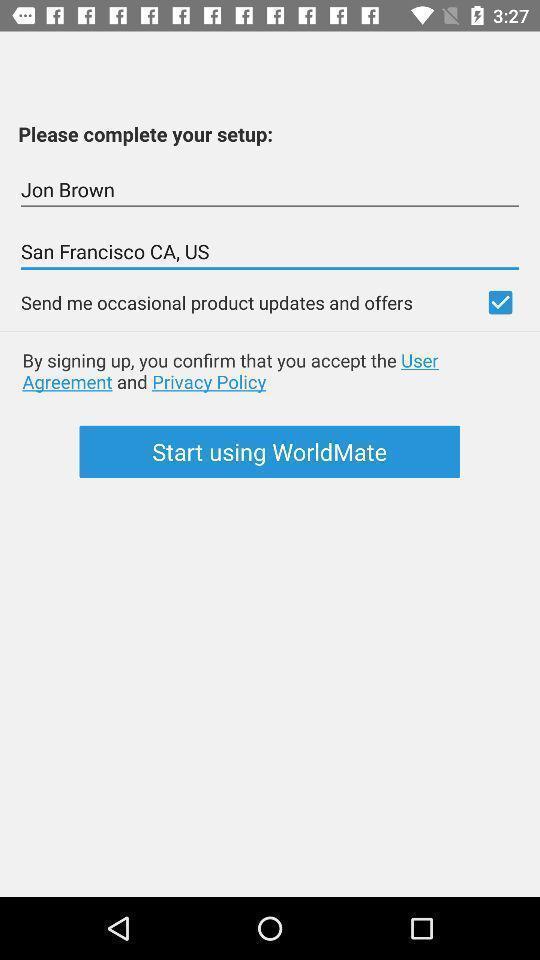Describe this image in words. Setup page displayed. 